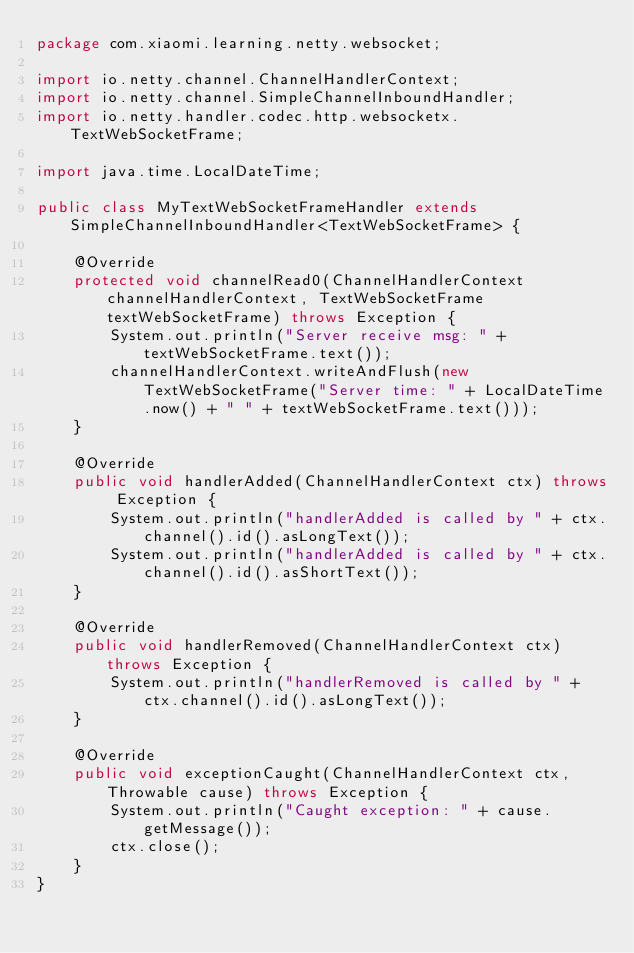<code> <loc_0><loc_0><loc_500><loc_500><_Java_>package com.xiaomi.learning.netty.websocket;

import io.netty.channel.ChannelHandlerContext;
import io.netty.channel.SimpleChannelInboundHandler;
import io.netty.handler.codec.http.websocketx.TextWebSocketFrame;

import java.time.LocalDateTime;

public class MyTextWebSocketFrameHandler extends SimpleChannelInboundHandler<TextWebSocketFrame> {

    @Override
    protected void channelRead0(ChannelHandlerContext channelHandlerContext, TextWebSocketFrame textWebSocketFrame) throws Exception {
        System.out.println("Server receive msg: " + textWebSocketFrame.text());
        channelHandlerContext.writeAndFlush(new TextWebSocketFrame("Server time: " + LocalDateTime.now() + " " + textWebSocketFrame.text()));
    }

    @Override
    public void handlerAdded(ChannelHandlerContext ctx) throws Exception {
        System.out.println("handlerAdded is called by " + ctx.channel().id().asLongText());
        System.out.println("handlerAdded is called by " + ctx.channel().id().asShortText());
    }

    @Override
    public void handlerRemoved(ChannelHandlerContext ctx) throws Exception {
        System.out.println("handlerRemoved is called by " + ctx.channel().id().asLongText());
    }

    @Override
    public void exceptionCaught(ChannelHandlerContext ctx, Throwable cause) throws Exception {
        System.out.println("Caught exception: " + cause.getMessage());
        ctx.close();
    }
}
</code> 